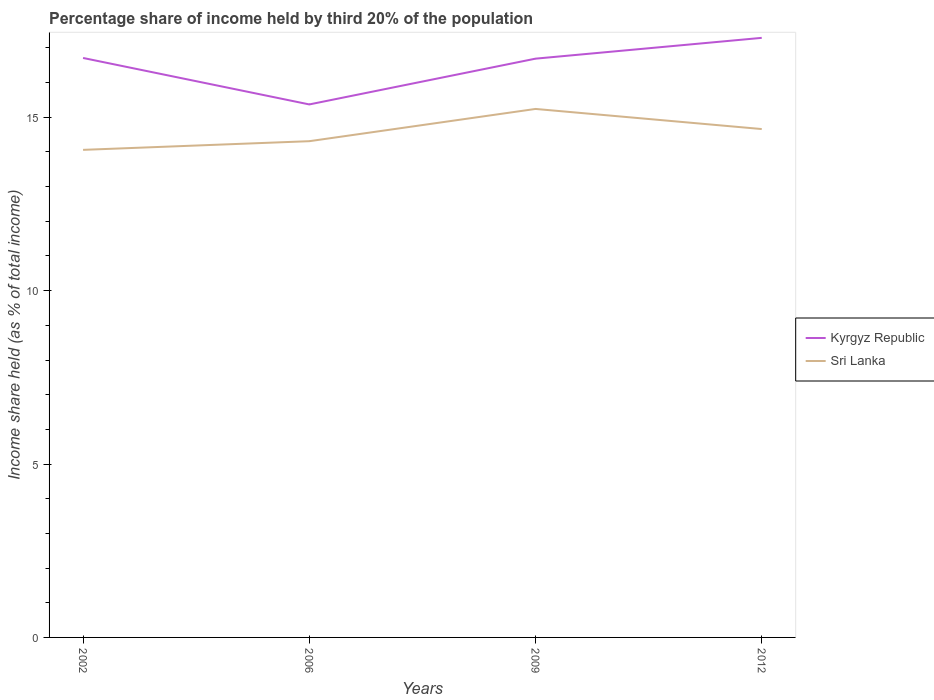How many different coloured lines are there?
Give a very brief answer. 2. Does the line corresponding to Kyrgyz Republic intersect with the line corresponding to Sri Lanka?
Make the answer very short. No. Across all years, what is the maximum share of income held by third 20% of the population in Kyrgyz Republic?
Your answer should be very brief. 15.37. What is the total share of income held by third 20% of the population in Sri Lanka in the graph?
Keep it short and to the point. -0.93. What is the difference between the highest and the second highest share of income held by third 20% of the population in Sri Lanka?
Offer a very short reply. 1.18. What is the difference between the highest and the lowest share of income held by third 20% of the population in Sri Lanka?
Give a very brief answer. 2. How many lines are there?
Provide a succinct answer. 2. How many years are there in the graph?
Keep it short and to the point. 4. Does the graph contain any zero values?
Provide a short and direct response. No. How are the legend labels stacked?
Provide a short and direct response. Vertical. What is the title of the graph?
Provide a short and direct response. Percentage share of income held by third 20% of the population. Does "Uganda" appear as one of the legend labels in the graph?
Provide a succinct answer. No. What is the label or title of the X-axis?
Give a very brief answer. Years. What is the label or title of the Y-axis?
Provide a succinct answer. Income share held (as % of total income). What is the Income share held (as % of total income) of Kyrgyz Republic in 2002?
Make the answer very short. 16.71. What is the Income share held (as % of total income) of Sri Lanka in 2002?
Your answer should be very brief. 14.06. What is the Income share held (as % of total income) in Kyrgyz Republic in 2006?
Offer a very short reply. 15.37. What is the Income share held (as % of total income) of Sri Lanka in 2006?
Your answer should be compact. 14.31. What is the Income share held (as % of total income) of Kyrgyz Republic in 2009?
Your response must be concise. 16.69. What is the Income share held (as % of total income) in Sri Lanka in 2009?
Your response must be concise. 15.24. What is the Income share held (as % of total income) of Kyrgyz Republic in 2012?
Your answer should be very brief. 17.29. What is the Income share held (as % of total income) of Sri Lanka in 2012?
Your answer should be compact. 14.66. Across all years, what is the maximum Income share held (as % of total income) of Kyrgyz Republic?
Provide a succinct answer. 17.29. Across all years, what is the maximum Income share held (as % of total income) of Sri Lanka?
Ensure brevity in your answer.  15.24. Across all years, what is the minimum Income share held (as % of total income) of Kyrgyz Republic?
Provide a short and direct response. 15.37. Across all years, what is the minimum Income share held (as % of total income) in Sri Lanka?
Provide a short and direct response. 14.06. What is the total Income share held (as % of total income) in Kyrgyz Republic in the graph?
Offer a very short reply. 66.06. What is the total Income share held (as % of total income) in Sri Lanka in the graph?
Offer a terse response. 58.27. What is the difference between the Income share held (as % of total income) of Kyrgyz Republic in 2002 and that in 2006?
Your response must be concise. 1.34. What is the difference between the Income share held (as % of total income) of Sri Lanka in 2002 and that in 2009?
Keep it short and to the point. -1.18. What is the difference between the Income share held (as % of total income) in Kyrgyz Republic in 2002 and that in 2012?
Provide a short and direct response. -0.58. What is the difference between the Income share held (as % of total income) in Kyrgyz Republic in 2006 and that in 2009?
Provide a succinct answer. -1.32. What is the difference between the Income share held (as % of total income) of Sri Lanka in 2006 and that in 2009?
Ensure brevity in your answer.  -0.93. What is the difference between the Income share held (as % of total income) of Kyrgyz Republic in 2006 and that in 2012?
Give a very brief answer. -1.92. What is the difference between the Income share held (as % of total income) in Sri Lanka in 2006 and that in 2012?
Provide a short and direct response. -0.35. What is the difference between the Income share held (as % of total income) in Kyrgyz Republic in 2009 and that in 2012?
Your response must be concise. -0.6. What is the difference between the Income share held (as % of total income) of Sri Lanka in 2009 and that in 2012?
Provide a short and direct response. 0.58. What is the difference between the Income share held (as % of total income) of Kyrgyz Republic in 2002 and the Income share held (as % of total income) of Sri Lanka in 2006?
Your answer should be very brief. 2.4. What is the difference between the Income share held (as % of total income) of Kyrgyz Republic in 2002 and the Income share held (as % of total income) of Sri Lanka in 2009?
Provide a short and direct response. 1.47. What is the difference between the Income share held (as % of total income) of Kyrgyz Republic in 2002 and the Income share held (as % of total income) of Sri Lanka in 2012?
Provide a short and direct response. 2.05. What is the difference between the Income share held (as % of total income) of Kyrgyz Republic in 2006 and the Income share held (as % of total income) of Sri Lanka in 2009?
Ensure brevity in your answer.  0.13. What is the difference between the Income share held (as % of total income) of Kyrgyz Republic in 2006 and the Income share held (as % of total income) of Sri Lanka in 2012?
Offer a terse response. 0.71. What is the difference between the Income share held (as % of total income) in Kyrgyz Republic in 2009 and the Income share held (as % of total income) in Sri Lanka in 2012?
Provide a short and direct response. 2.03. What is the average Income share held (as % of total income) in Kyrgyz Republic per year?
Your answer should be very brief. 16.52. What is the average Income share held (as % of total income) of Sri Lanka per year?
Give a very brief answer. 14.57. In the year 2002, what is the difference between the Income share held (as % of total income) of Kyrgyz Republic and Income share held (as % of total income) of Sri Lanka?
Your answer should be very brief. 2.65. In the year 2006, what is the difference between the Income share held (as % of total income) in Kyrgyz Republic and Income share held (as % of total income) in Sri Lanka?
Provide a succinct answer. 1.06. In the year 2009, what is the difference between the Income share held (as % of total income) of Kyrgyz Republic and Income share held (as % of total income) of Sri Lanka?
Your response must be concise. 1.45. In the year 2012, what is the difference between the Income share held (as % of total income) of Kyrgyz Republic and Income share held (as % of total income) of Sri Lanka?
Your answer should be compact. 2.63. What is the ratio of the Income share held (as % of total income) in Kyrgyz Republic in 2002 to that in 2006?
Keep it short and to the point. 1.09. What is the ratio of the Income share held (as % of total income) of Sri Lanka in 2002 to that in 2006?
Your response must be concise. 0.98. What is the ratio of the Income share held (as % of total income) of Kyrgyz Republic in 2002 to that in 2009?
Your answer should be very brief. 1. What is the ratio of the Income share held (as % of total income) of Sri Lanka in 2002 to that in 2009?
Make the answer very short. 0.92. What is the ratio of the Income share held (as % of total income) of Kyrgyz Republic in 2002 to that in 2012?
Make the answer very short. 0.97. What is the ratio of the Income share held (as % of total income) in Sri Lanka in 2002 to that in 2012?
Make the answer very short. 0.96. What is the ratio of the Income share held (as % of total income) of Kyrgyz Republic in 2006 to that in 2009?
Give a very brief answer. 0.92. What is the ratio of the Income share held (as % of total income) in Sri Lanka in 2006 to that in 2009?
Give a very brief answer. 0.94. What is the ratio of the Income share held (as % of total income) of Kyrgyz Republic in 2006 to that in 2012?
Offer a very short reply. 0.89. What is the ratio of the Income share held (as % of total income) in Sri Lanka in 2006 to that in 2012?
Keep it short and to the point. 0.98. What is the ratio of the Income share held (as % of total income) in Kyrgyz Republic in 2009 to that in 2012?
Provide a short and direct response. 0.97. What is the ratio of the Income share held (as % of total income) in Sri Lanka in 2009 to that in 2012?
Your response must be concise. 1.04. What is the difference between the highest and the second highest Income share held (as % of total income) of Kyrgyz Republic?
Give a very brief answer. 0.58. What is the difference between the highest and the second highest Income share held (as % of total income) of Sri Lanka?
Give a very brief answer. 0.58. What is the difference between the highest and the lowest Income share held (as % of total income) in Kyrgyz Republic?
Your answer should be very brief. 1.92. What is the difference between the highest and the lowest Income share held (as % of total income) of Sri Lanka?
Provide a succinct answer. 1.18. 